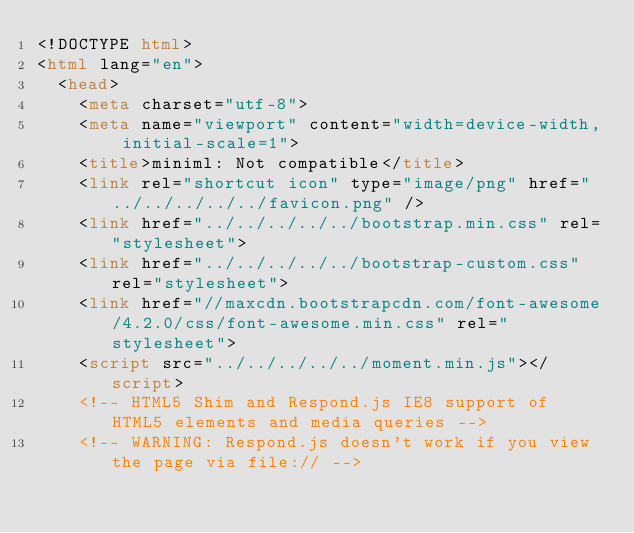<code> <loc_0><loc_0><loc_500><loc_500><_HTML_><!DOCTYPE html>
<html lang="en">
  <head>
    <meta charset="utf-8">
    <meta name="viewport" content="width=device-width, initial-scale=1">
    <title>miniml: Not compatible</title>
    <link rel="shortcut icon" type="image/png" href="../../../../../favicon.png" />
    <link href="../../../../../bootstrap.min.css" rel="stylesheet">
    <link href="../../../../../bootstrap-custom.css" rel="stylesheet">
    <link href="//maxcdn.bootstrapcdn.com/font-awesome/4.2.0/css/font-awesome.min.css" rel="stylesheet">
    <script src="../../../../../moment.min.js"></script>
    <!-- HTML5 Shim and Respond.js IE8 support of HTML5 elements and media queries -->
    <!-- WARNING: Respond.js doesn't work if you view the page via file:// --></code> 